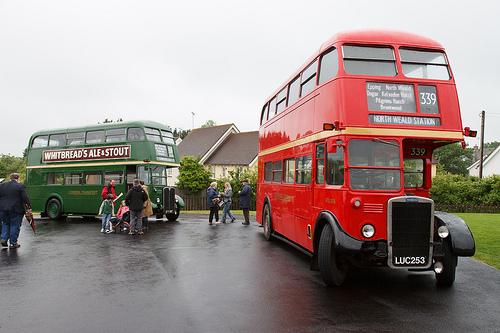Provide a short narrative of the scene depicted in the image. On a cloudy day with wet pavement, people gather around two double-decker buses, one red and one green. Some individuals chat in groups, while two ladies seem ready to fight. A child in a green vest is also present. Determine the outdoor visibility in the image based on the sky and weather conditions. The outdoor visibility seems to be moderate due to the overcast and cloudy sky. List two interesting details about the buses in the image. One bus has 339 on the front, and the other bus has a license tag that reads LUC253. Describe the group of people in the image and their possible interactions. The group of people consists of men and women, some standing around chatting, others appearing ready to fight, and a little child in a green vest. They seem to be engaged in various conversations and interactions near the buses. Examine the image and identify the number of buses present and their colors. There are two buses - one is red, and the other is green. Identify two objects in the image that are interacting with each other and describe their interaction. Two double-decker buses, one red and one green, are parked close to each other on a wet paved pavement. Identify any text or signs that can be found in the image. There is a sign that says "Whitbreads Ale Stout" and bus destination signs. How many people can be seen in the image, and what is the overall sentiment of the scene? There are at least 8 people in the image, and the overall sentiment is neutral with a slightly tense undertone as two ladies seem ready to fight. What is the most prominent color in the image and in which objects can it be found? The most prominent color in the image is red, which can be found in the double-decker bus, a man's jacket, and several additional indicators that the bus is red. Describe the weather conditions and the general environment in the image. The weather is overcast with a cloudy sky, and the environment includes wet pavement, a green manicured lawn, and a white house with a brown roof. Is there a rainbow visible in the overcast cloudy sky? No, it's not mentioned in the image. 